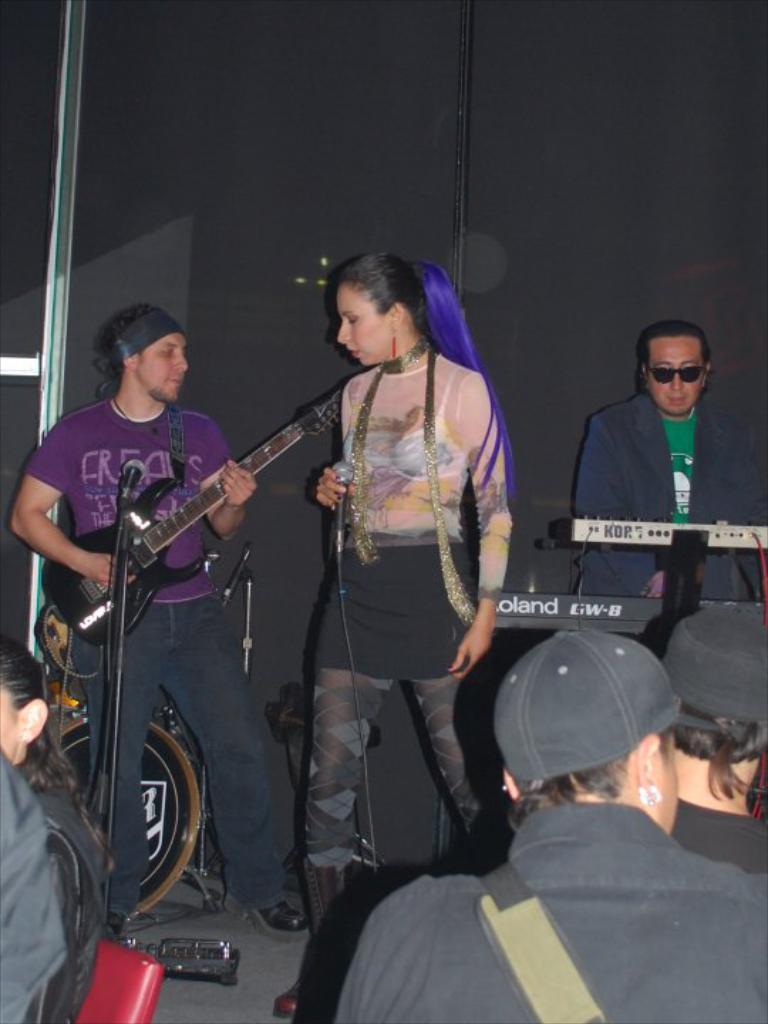Please provide a concise description of this image. In this picture I can see a man playing a guitar and a woman holding a microphone and standing and I can see another man playing a piano and I can see few people are sitting in the chairs and I can see a drum and a black cloth in the back. 